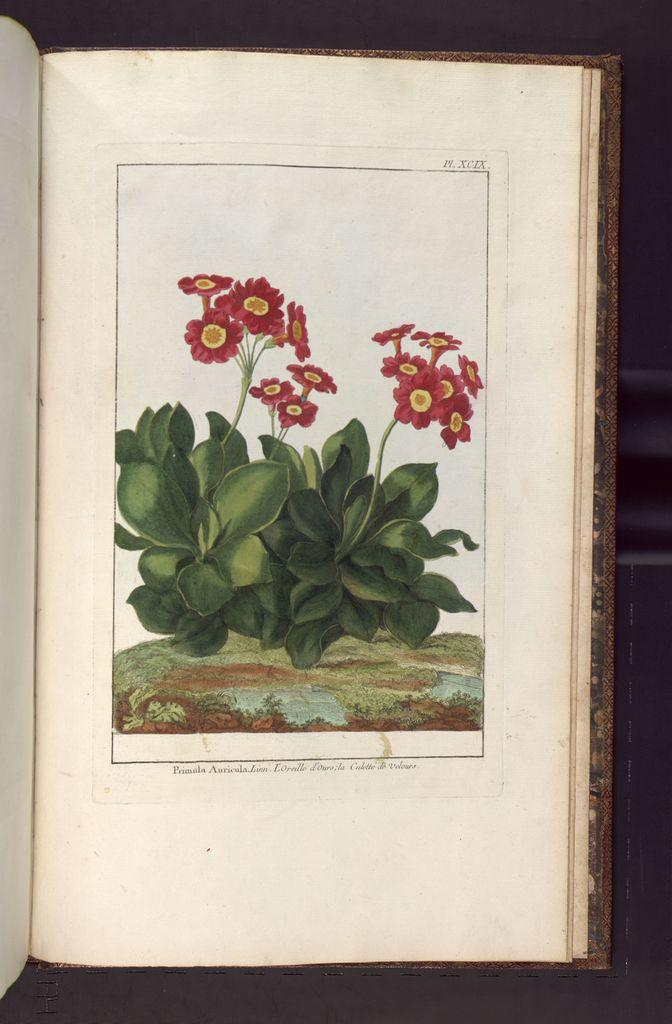What is the main object in the image? There is a book in the image. What type of content does the book contain? The book contains art. What type of milk is being used to create the art in the book? There is no milk present in the image, as the book contains art, not milk. 